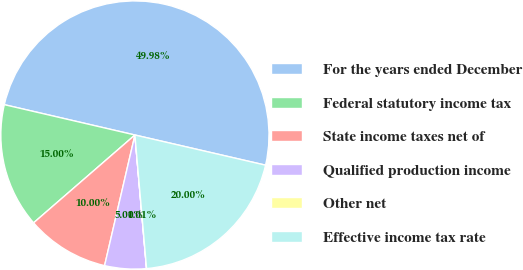Convert chart. <chart><loc_0><loc_0><loc_500><loc_500><pie_chart><fcel>For the years ended December<fcel>Federal statutory income tax<fcel>State income taxes net of<fcel>Qualified production income<fcel>Other net<fcel>Effective income tax rate<nl><fcel>49.98%<fcel>15.0%<fcel>10.0%<fcel>5.01%<fcel>0.01%<fcel>20.0%<nl></chart> 